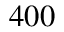Convert formula to latex. <formula><loc_0><loc_0><loc_500><loc_500>4 0 0</formula> 